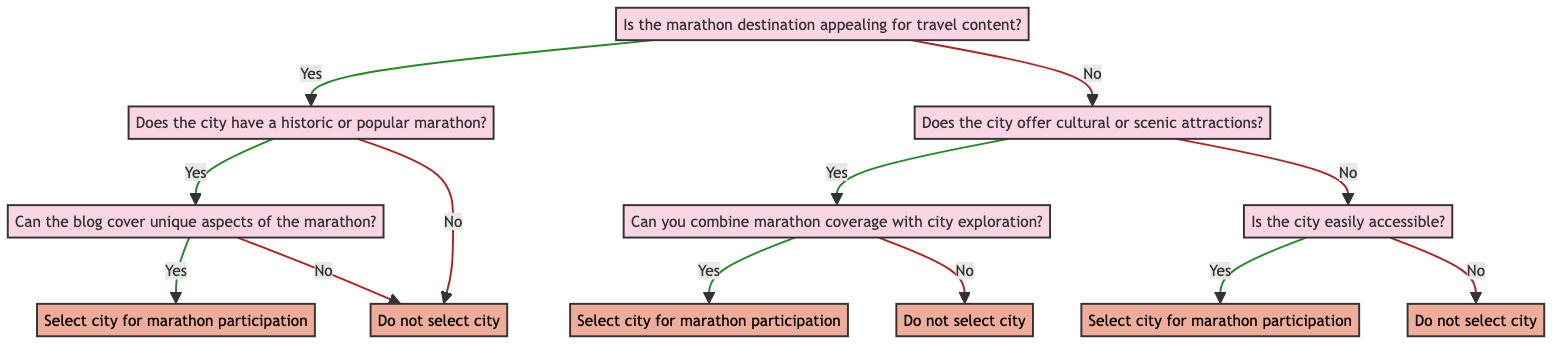What is the first question in the decision tree? The first question in the decision tree is located at the top node and asks whether "Is the marathon destination appealing for travel content?"
Answer: Is the marathon destination appealing for travel content? How many decisions are there in total? To find the total number of decisions, we can count each decision node: there are five decisions labeled as "Select city for marathon participation" and "Do not select city."
Answer: Five What happens if the city has a historic or popular marathon but no unique aspects? If the city has a historic or popular marathon but no unique aspects to cover, the decision made is to "Do not select city" because there is a lack of unique content for blogging.
Answer: Do not select city What is the outcome if the city is not appealing for travel content but offers cultural attractions? If the city is not appealing for travel content but offers cultural attractions, the next decision point asks if you can combine marathon coverage with city exploration. The answer could lead to either selecting or not selecting the city based on the answer to that question.
Answer: Depends on the combination outcome What is the reason for selecting a city if it is easily accessible? The reason for selecting a city if it is easily accessible is because it allows for convenient travel, even if the city has less standout attractions.
Answer: Convenient travel despite less standout attractions What is the outcome if the city is not appealing for travel content and does not offer cultural attractions? If the city is not appealing for travel content and does not offer cultural attractions, the final question determines if the city is easily accessible. If it is not accessible, the decision is to "Do not select city" due to logistical challenges.
Answer: Do not select city How many questions are asked in total before reaching a decision? The diagram contains a total of six questions before reaching various decisions. The flow counts each question from start to finish.
Answer: Six What occurs if the city has cultural attractions but no possibility to combine marathon coverage with city exploration? If the city has cultural attractions but cannot combine marathon coverage with city exploration, the decision will be to "Do not select city" as it lacks coherent travel blog content.
Answer: Do not select city 